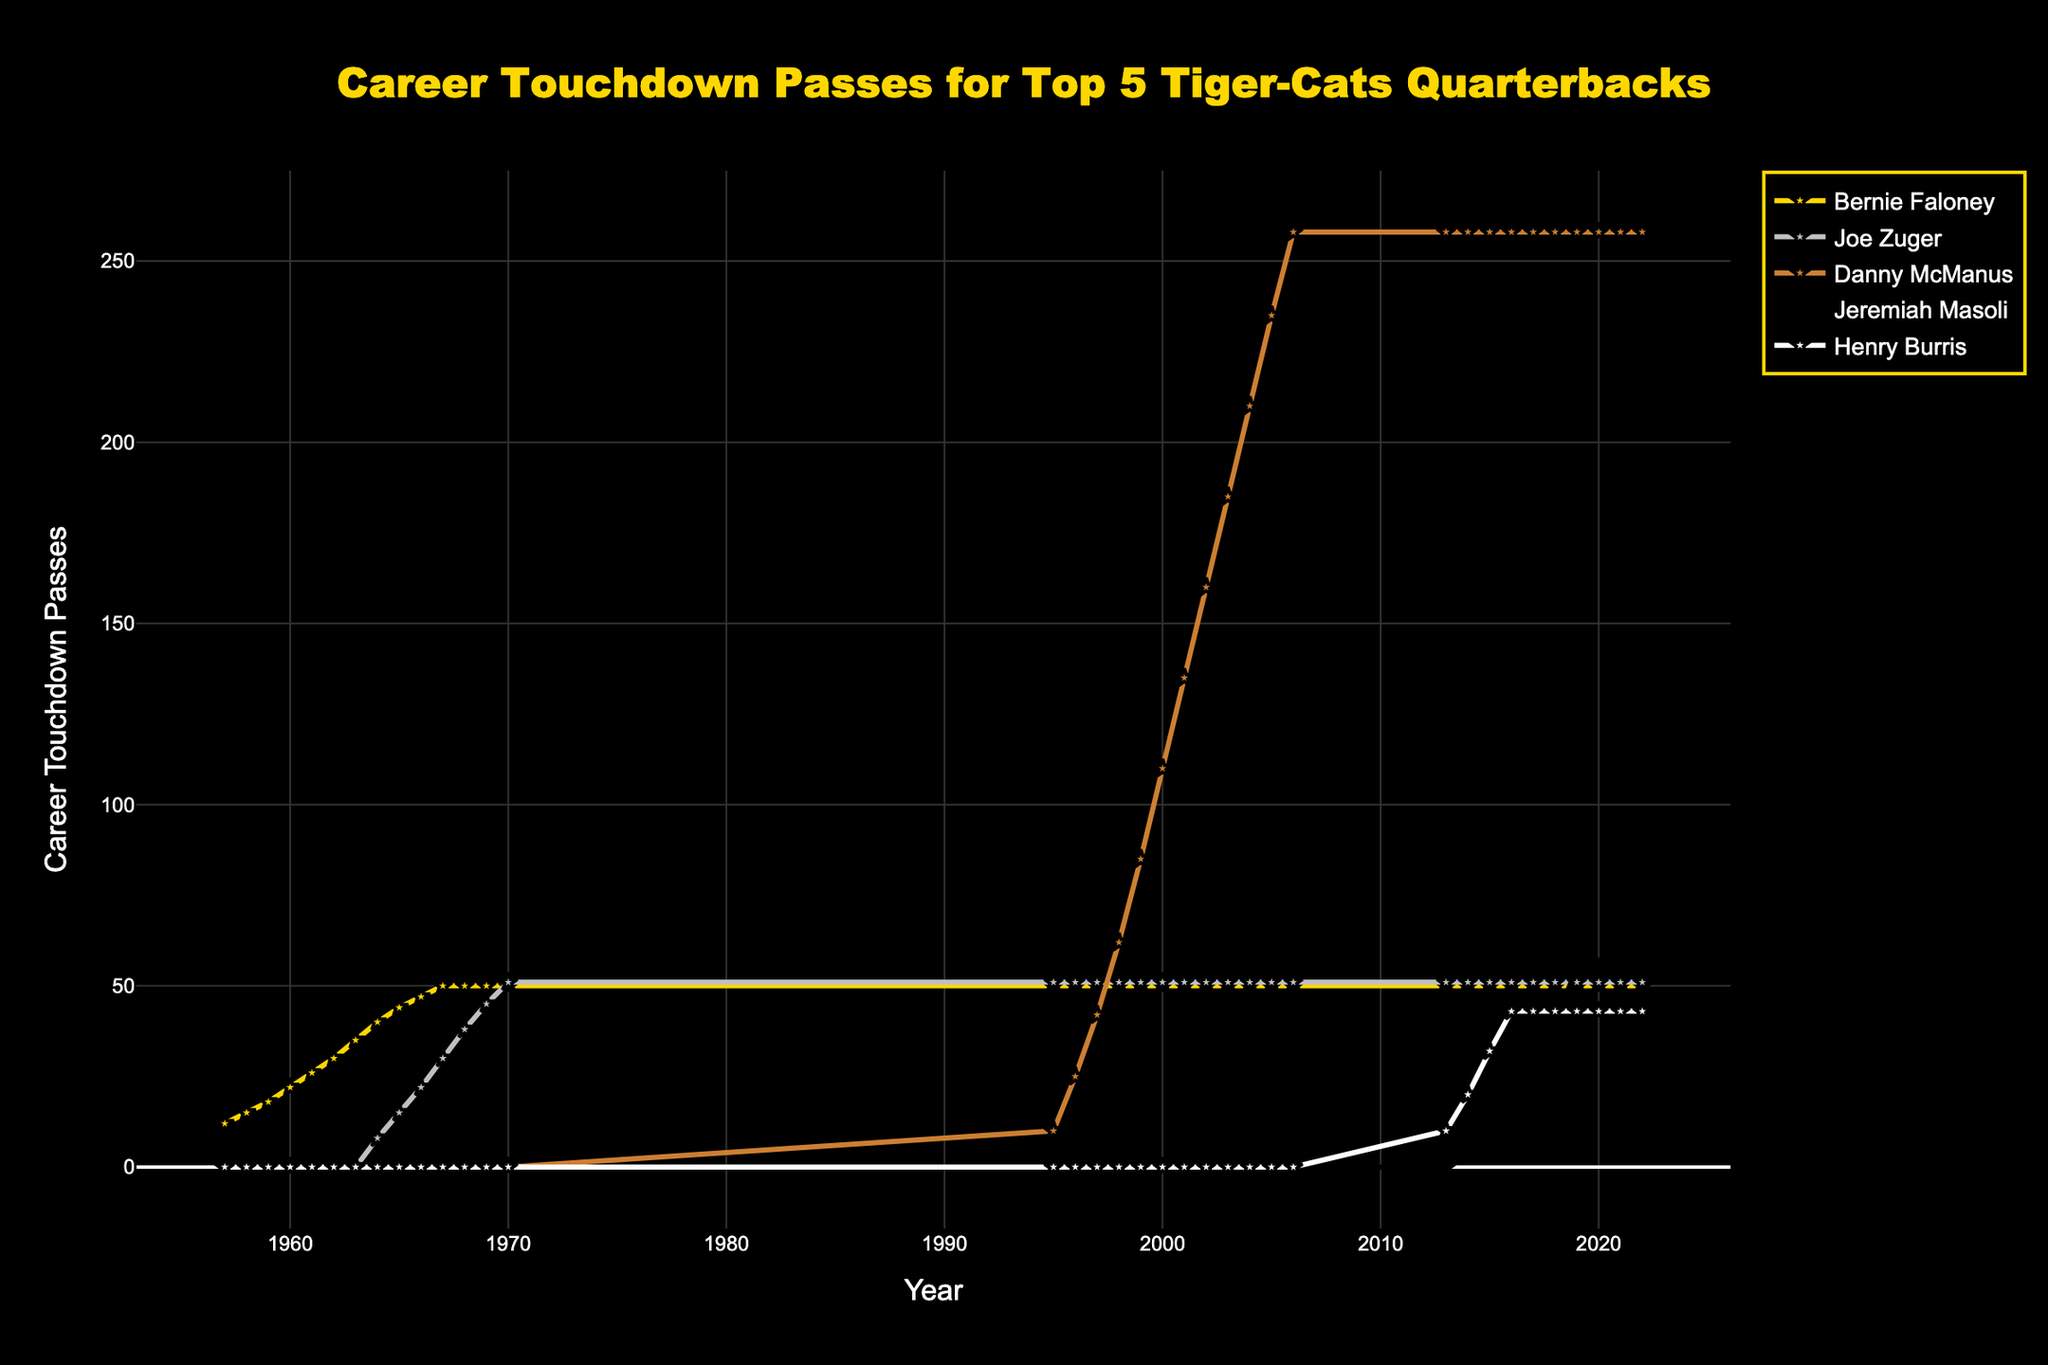What's the total career touchdown passes of Bernie Faloney and Danny McManus in 2005? Sum the career touchdown passes of Bernie Faloney (50) and Danny McManus (235) in 2005. 50 + 235 = 285.
Answer: 285 Who had more career touchdown passes in 1970, Bernie Faloney or Joe Zuger? Compare the number of career touchdown passes in 1970: Bernie Faloney had 50 while Joe Zuger had 51.
Answer: Joe Zuger Which quarterback first crossed 40 career touchdown passes? Identify the year each quarterback passed 40 career touchdown passes and determine the earliest: Bernie Faloney in 1964 was the first.
Answer: Bernie Faloney By how many touchdown passes did Jeremiah Masoli surpass Henry Burris in 2019? Subtract the career touchdown passes of Henry Burris (43) from Jeremiah Masoli (55) in 2019. 55 - 43 = 12.
Answer: 12 What are the colors of the lines representing Henry Burris and Bernie Faloney? The color representing Henry Burris is white, and the color representing Bernie Faloney is gold.
Answer: White and gold During which period did Danny McManus's career touchdown passes increase the fastest? Identify the years showing the steepest slope for Danny McManus. The period from 1996 to 1999 shows the fastest increase from 25 to 85.
Answer: 1996-1999 Whose career touchdown passes remained constant after reaching 50? Observe the lines and identify whose passes stopped increasing after 50: Bernie Faloney after 1970 and Joe Zuger after 1970.
Answer: Bernie Faloney and Joe Zuger How many more career touchdown passes did Joe Zuger have than Henry Burris as of 2022? Subtract Henry Burris’s career touchdown passes (43) from Joe Zuger's (51) as of 2022. 51 - 43 = 8.
Answer: 8 Which quarterback's line color is black, and how many touchdown passes does he have in 1999? Identify the quarterback with a black line and the number of touchdown passes he had in 1999: Danny McManus had 85 touchdown passes.
Answer: Danny McManus and 85 